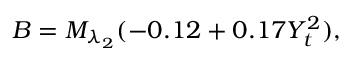<formula> <loc_0><loc_0><loc_500><loc_500>B = M _ { \lambda _ { 2 } } ( - 0 . 1 2 + 0 . 1 7 Y _ { t } ^ { 2 } ) ,</formula> 